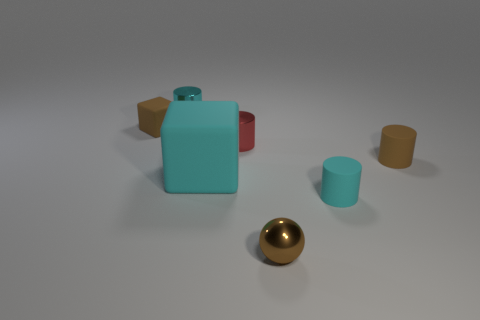Subtract all small red cylinders. How many cylinders are left? 3 Subtract all red cubes. How many cyan cylinders are left? 2 Add 2 big red spheres. How many objects exist? 9 Subtract all red cylinders. How many cylinders are left? 3 Subtract 2 cylinders. How many cylinders are left? 2 Add 2 brown cylinders. How many brown cylinders exist? 3 Subtract 0 yellow cylinders. How many objects are left? 7 Subtract all spheres. How many objects are left? 6 Subtract all purple cylinders. Subtract all green spheres. How many cylinders are left? 4 Subtract all tiny blue things. Subtract all small cylinders. How many objects are left? 3 